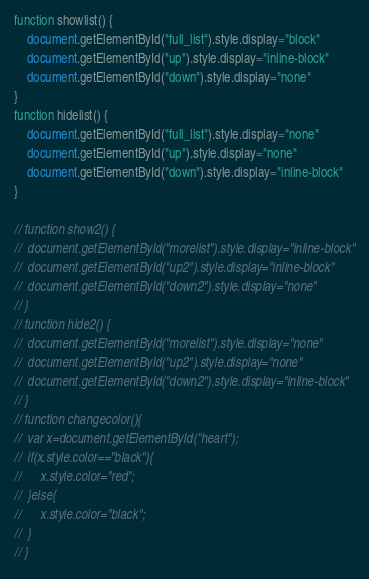<code> <loc_0><loc_0><loc_500><loc_500><_JavaScript_>function showlist() {
	document.getElementById("full_list").style.display="block"
	document.getElementById("up").style.display="inline-block"
	document.getElementById("down").style.display="none"
}
function hidelist() {
	document.getElementById("full_list").style.display="none"
	document.getElementById("up").style.display="none"
	document.getElementById("down").style.display="inline-block"
}

// function show2() {
// 	document.getElementById("morelist").style.display="inline-block"
// 	document.getElementById("up2").style.display="inline-block"
// 	document.getElementById("down2").style.display="none"
// }
// function hide2() {
// 	document.getElementById("morelist").style.display="none"
// 	document.getElementById("up2").style.display="none"
// 	document.getElementById("down2").style.display="inline-block"
// }
// function changecolor(){
// 	var x=document.getElementById("heart");
// 	if(x.style.color=="black"){
// 		x.style.color="red";
// 	}else{
// 		x.style.color="black";
// 	}
// }</code> 